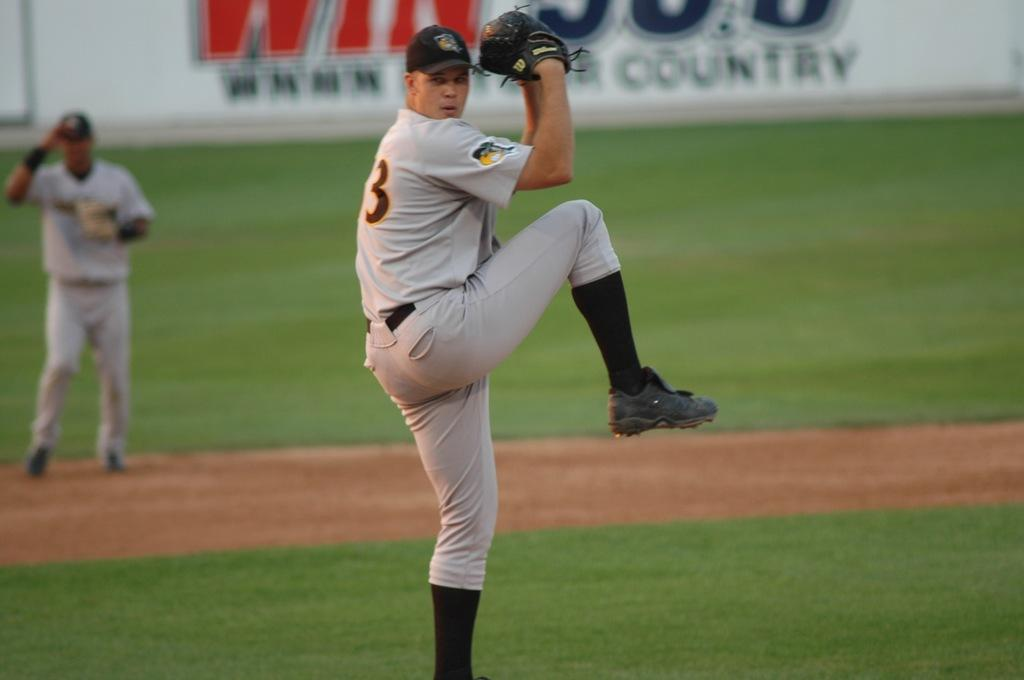<image>
Present a compact description of the photo's key features. Baseball player wearing the numbe 3 about to pitch. 